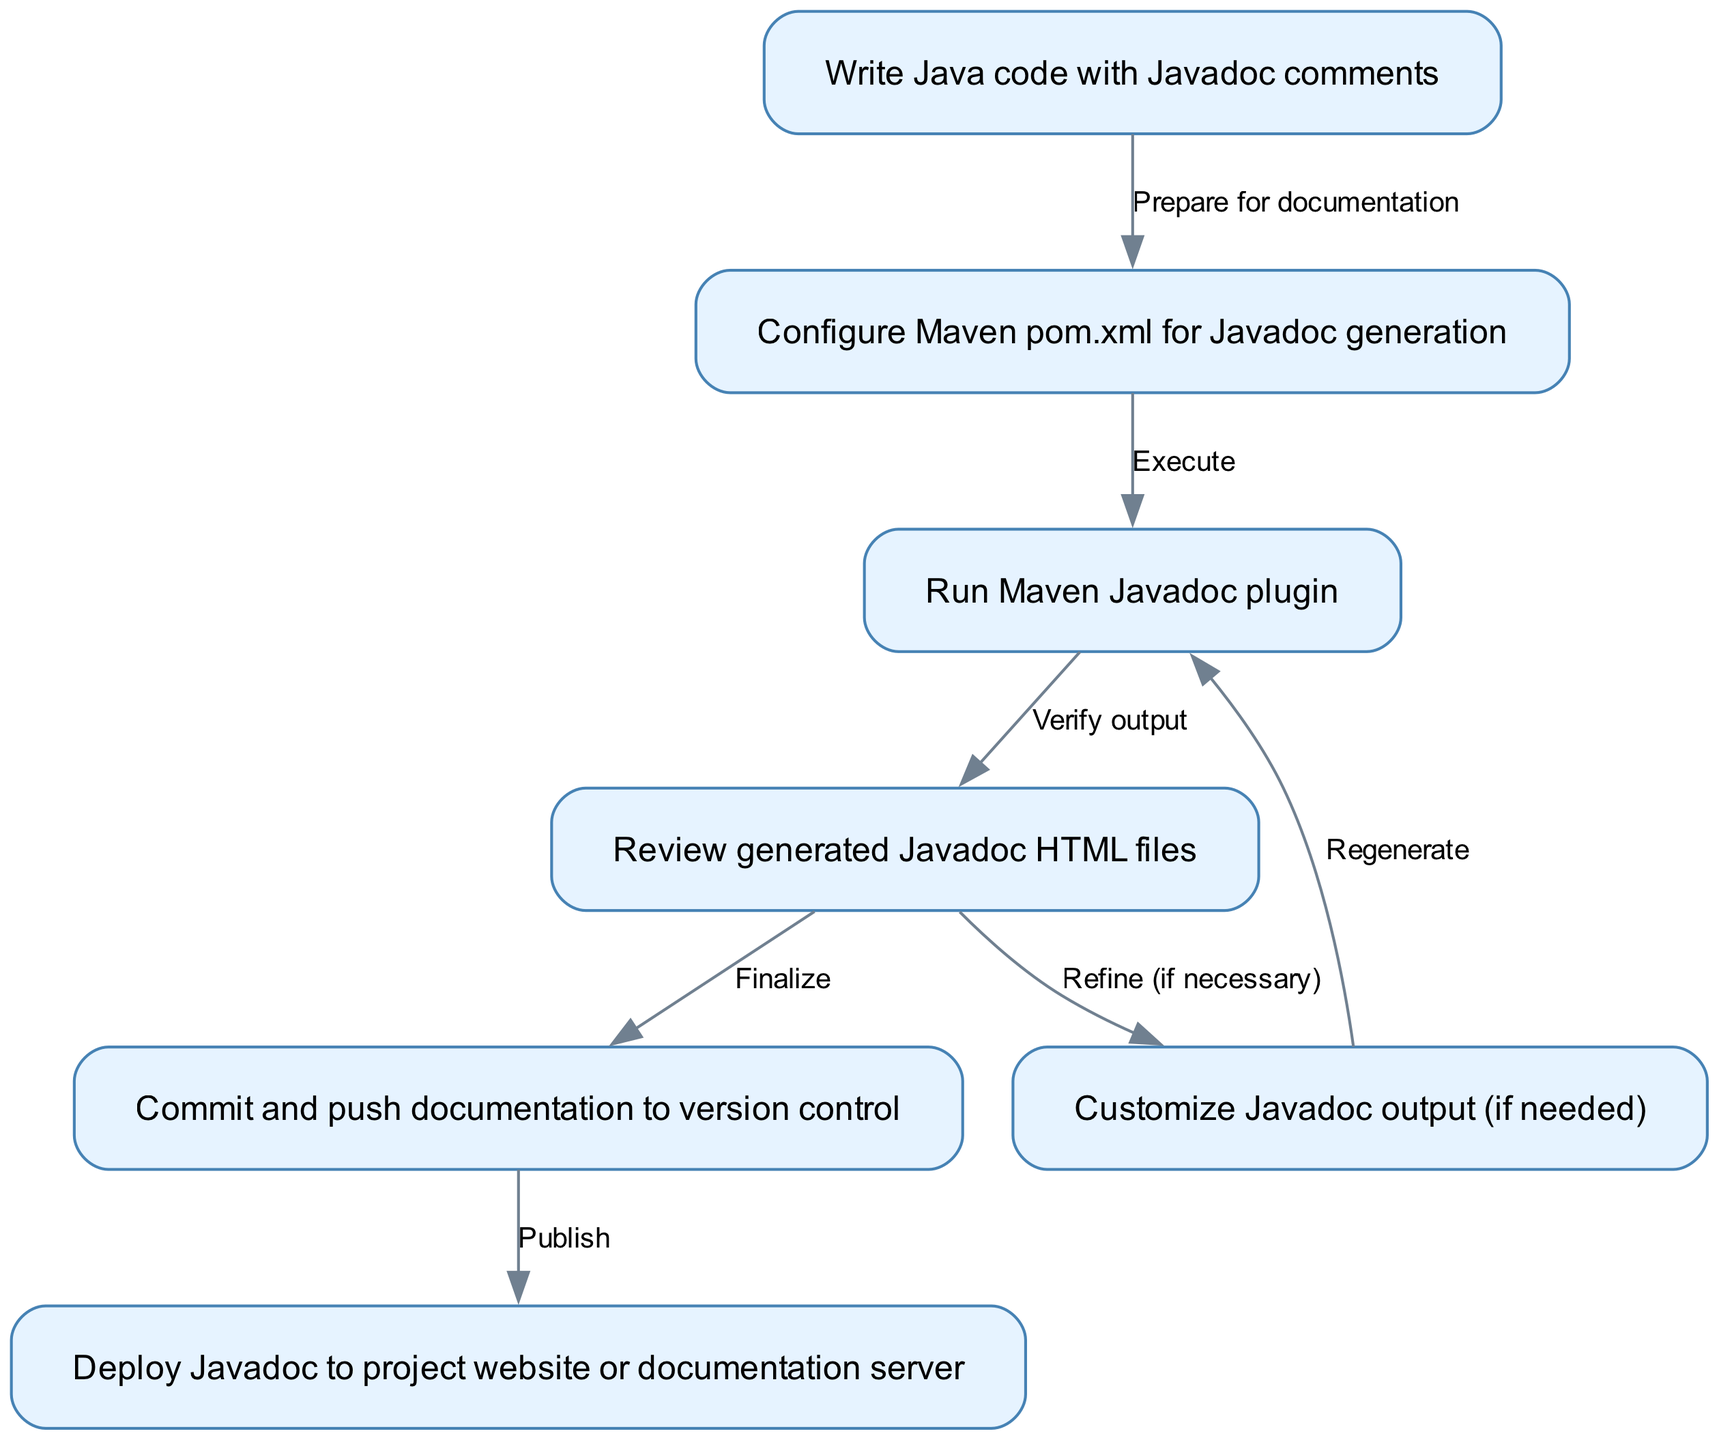What is the first step in the process? The first node in the flow chart indicates "Write Java code with Javadoc comments" as the starting point of the process.
Answer: Write Java code with Javadoc comments How many nodes are present in the flow chart? By counting each node listed in the "nodes" section, we find a total of 7 distinct processes or steps involved.
Answer: 7 What is the final step in the sequence? The last node in the flow chart denotes "Deploy Javadoc to project website or documentation server," signifying the completion of the process.
Answer: Deploy Javadoc to project website or documentation server What action follows reviewing the generated Javadoc HTML files? The edge from node 4 to node 5 indicates that after reviewing, the next action is to "Customize Javadoc output (if needed)."
Answer: Customize Javadoc output (if needed) How many edges connect the nodes in the diagram? By counting the connections in the "edges" section, we determine that there are 6 relationships that depict the flow from one step to another.
Answer: 6 Which step is performed after configuring Maven pom.xml for Javadoc generation? The flow from node 2 to node 3 shows that the next action to be executed is "Run Maven Javadoc plugin" immediately after configuration.
Answer: Run Maven Javadoc plugin What happens if customization of Javadoc output is needed? The diagram indicates that if customization is necessary (from node 5), the flow returns to "Run Maven Javadoc plugin" (node 3) to regenerate the documentation.
Answer: Regenerate How are the nodes connected to show the process flow? The edges provide a clear directional path from one node to the next, describing the sequential steps taken to create and publish Java documentation through arrows labeled with action phrases.
Answer: Edges show the process flow What is the action taken after committing and pushing documentation? The edge leading from node 6 to node 7 specifies that the next step after committing is to "Deploy Javadoc to project website or documentation server."
Answer: Deploy Javadoc to project website or documentation server 